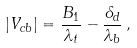Convert formula to latex. <formula><loc_0><loc_0><loc_500><loc_500>| V _ { c b } | = { \frac { B _ { 1 } } { \lambda _ { t } } } - { \frac { \delta _ { d } } { \lambda _ { b } } } \, ,</formula> 